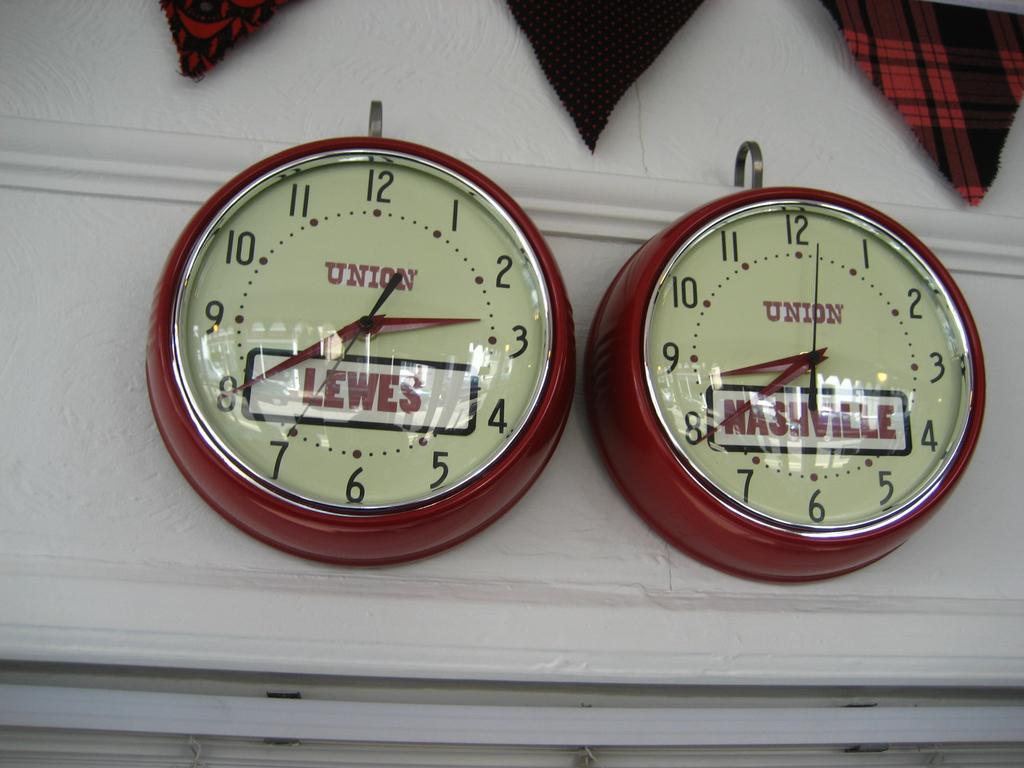What are the times on the two clocks?
Offer a terse response. 2:40 and 8:40. What words can be seen on either clocks?
Give a very brief answer. Union. 